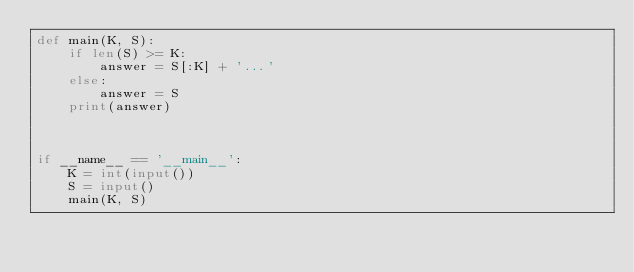<code> <loc_0><loc_0><loc_500><loc_500><_Python_>def main(K, S):
    if len(S) >= K:
        answer = S[:K] + '...'
    else:
        answer = S
    print(answer)



if __name__ == '__main__':
    K = int(input())
    S = input()
    main(K, S)
</code> 